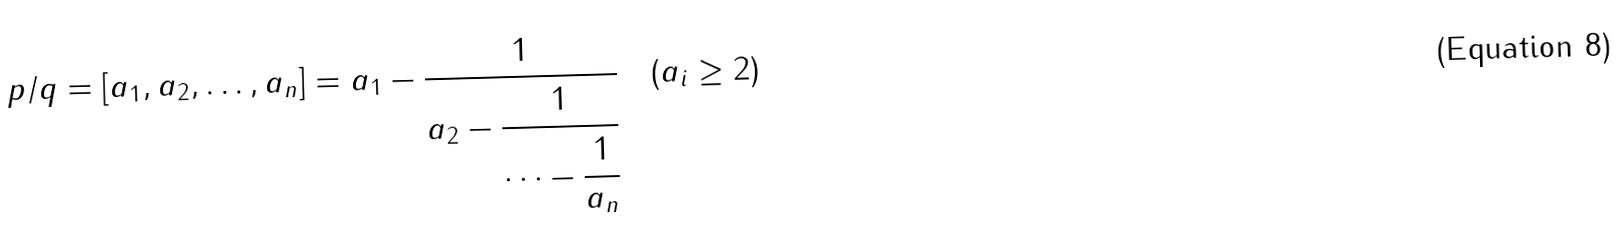Convert formula to latex. <formula><loc_0><loc_0><loc_500><loc_500>p / q = [ a _ { 1 } , a _ { 2 } , \dots , a _ { n } ] = a _ { 1 } - \cfrac { 1 } { a _ { 2 } - \cfrac { 1 } { \dots - \cfrac { 1 } { a _ { n } } } } \quad ( a _ { i } \geq 2 )</formula> 